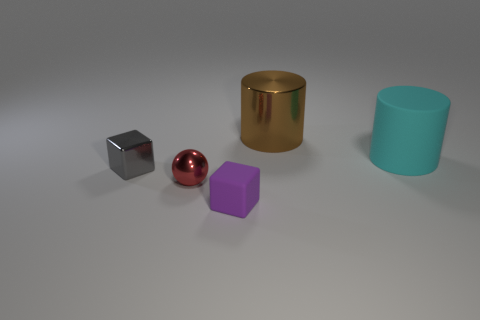Subtract all green rubber cubes. Subtract all small purple things. How many objects are left? 4 Add 4 gray metal cubes. How many gray metal cubes are left? 5 Add 2 blue shiny cylinders. How many blue shiny cylinders exist? 2 Add 5 brown metallic cylinders. How many objects exist? 10 Subtract 0 blue cubes. How many objects are left? 5 Subtract all spheres. How many objects are left? 4 Subtract all blue cubes. Subtract all red cylinders. How many cubes are left? 2 Subtract all purple balls. How many purple cubes are left? 1 